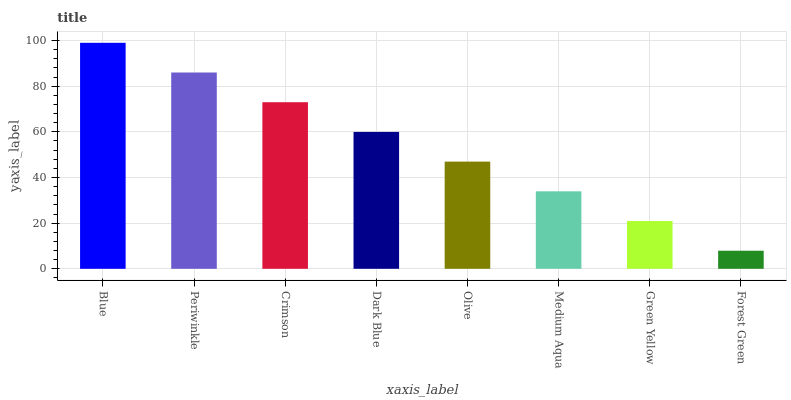Is Forest Green the minimum?
Answer yes or no. Yes. Is Blue the maximum?
Answer yes or no. Yes. Is Periwinkle the minimum?
Answer yes or no. No. Is Periwinkle the maximum?
Answer yes or no. No. Is Blue greater than Periwinkle?
Answer yes or no. Yes. Is Periwinkle less than Blue?
Answer yes or no. Yes. Is Periwinkle greater than Blue?
Answer yes or no. No. Is Blue less than Periwinkle?
Answer yes or no. No. Is Dark Blue the high median?
Answer yes or no. Yes. Is Olive the low median?
Answer yes or no. Yes. Is Medium Aqua the high median?
Answer yes or no. No. Is Medium Aqua the low median?
Answer yes or no. No. 